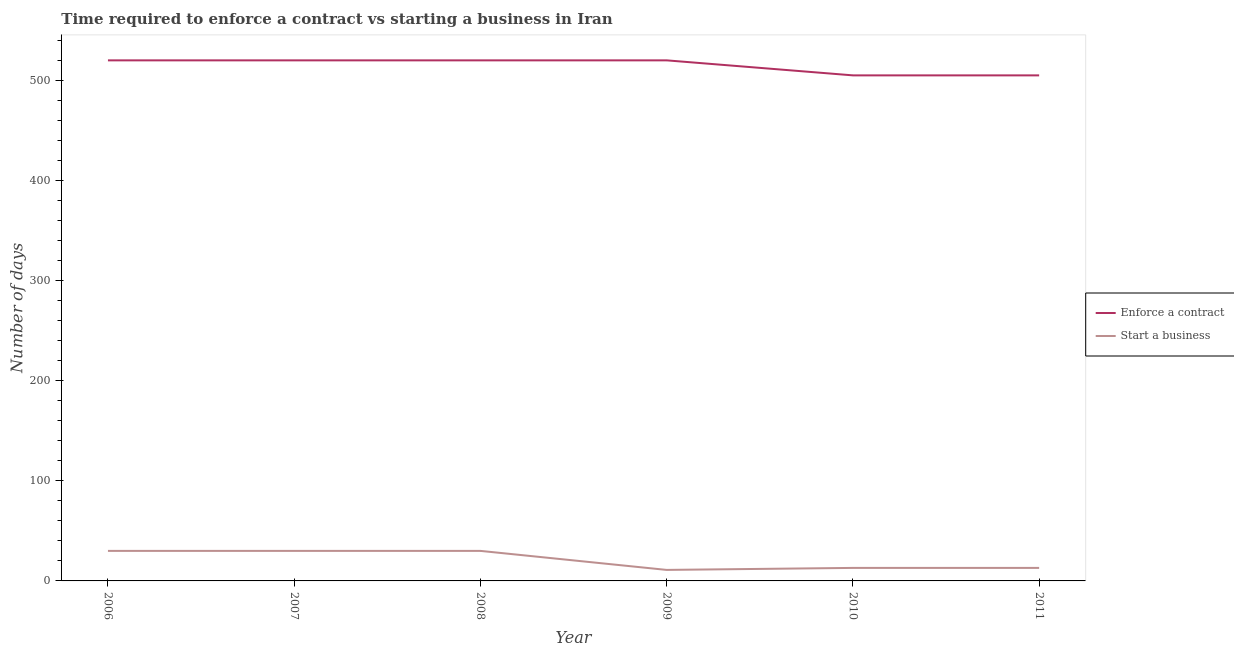How many different coloured lines are there?
Keep it short and to the point. 2. Does the line corresponding to number of days to enforece a contract intersect with the line corresponding to number of days to start a business?
Ensure brevity in your answer.  No. Is the number of lines equal to the number of legend labels?
Your response must be concise. Yes. What is the number of days to start a business in 2007?
Ensure brevity in your answer.  30. Across all years, what is the maximum number of days to start a business?
Provide a short and direct response. 30. Across all years, what is the minimum number of days to start a business?
Your answer should be very brief. 11. What is the total number of days to start a business in the graph?
Your answer should be very brief. 127. What is the difference between the number of days to enforece a contract in 2008 and the number of days to start a business in 2010?
Offer a terse response. 507. What is the average number of days to enforece a contract per year?
Offer a terse response. 515. In the year 2006, what is the difference between the number of days to start a business and number of days to enforece a contract?
Offer a very short reply. -490. In how many years, is the number of days to enforece a contract greater than 520 days?
Your answer should be compact. 0. What is the ratio of the number of days to start a business in 2007 to that in 2009?
Ensure brevity in your answer.  2.73. Is the difference between the number of days to start a business in 2009 and 2010 greater than the difference between the number of days to enforece a contract in 2009 and 2010?
Offer a terse response. No. What is the difference between the highest and the lowest number of days to enforece a contract?
Your answer should be compact. 15. In how many years, is the number of days to start a business greater than the average number of days to start a business taken over all years?
Offer a very short reply. 3. Does the number of days to start a business monotonically increase over the years?
Make the answer very short. No. Is the number of days to enforece a contract strictly less than the number of days to start a business over the years?
Ensure brevity in your answer.  No. How many years are there in the graph?
Provide a short and direct response. 6. What is the difference between two consecutive major ticks on the Y-axis?
Keep it short and to the point. 100. Does the graph contain grids?
Your answer should be very brief. No. Where does the legend appear in the graph?
Provide a succinct answer. Center right. How many legend labels are there?
Give a very brief answer. 2. What is the title of the graph?
Offer a terse response. Time required to enforce a contract vs starting a business in Iran. Does "Secondary education" appear as one of the legend labels in the graph?
Provide a succinct answer. No. What is the label or title of the Y-axis?
Your answer should be very brief. Number of days. What is the Number of days in Enforce a contract in 2006?
Offer a terse response. 520. What is the Number of days in Enforce a contract in 2007?
Your answer should be very brief. 520. What is the Number of days in Enforce a contract in 2008?
Provide a short and direct response. 520. What is the Number of days in Enforce a contract in 2009?
Give a very brief answer. 520. What is the Number of days of Start a business in 2009?
Provide a succinct answer. 11. What is the Number of days of Enforce a contract in 2010?
Your answer should be compact. 505. What is the Number of days in Start a business in 2010?
Keep it short and to the point. 13. What is the Number of days of Enforce a contract in 2011?
Make the answer very short. 505. What is the Number of days of Start a business in 2011?
Ensure brevity in your answer.  13. Across all years, what is the maximum Number of days of Enforce a contract?
Offer a terse response. 520. Across all years, what is the minimum Number of days of Enforce a contract?
Make the answer very short. 505. Across all years, what is the minimum Number of days of Start a business?
Your answer should be very brief. 11. What is the total Number of days of Enforce a contract in the graph?
Your response must be concise. 3090. What is the total Number of days of Start a business in the graph?
Make the answer very short. 127. What is the difference between the Number of days of Enforce a contract in 2006 and that in 2007?
Keep it short and to the point. 0. What is the difference between the Number of days of Start a business in 2006 and that in 2007?
Your response must be concise. 0. What is the difference between the Number of days of Start a business in 2006 and that in 2008?
Your answer should be compact. 0. What is the difference between the Number of days in Enforce a contract in 2006 and that in 2009?
Make the answer very short. 0. What is the difference between the Number of days in Enforce a contract in 2006 and that in 2010?
Provide a short and direct response. 15. What is the difference between the Number of days of Start a business in 2007 and that in 2008?
Make the answer very short. 0. What is the difference between the Number of days of Enforce a contract in 2007 and that in 2009?
Your answer should be very brief. 0. What is the difference between the Number of days of Enforce a contract in 2007 and that in 2010?
Your answer should be compact. 15. What is the difference between the Number of days in Start a business in 2007 and that in 2011?
Give a very brief answer. 17. What is the difference between the Number of days in Start a business in 2008 and that in 2009?
Offer a terse response. 19. What is the difference between the Number of days in Enforce a contract in 2008 and that in 2010?
Your response must be concise. 15. What is the difference between the Number of days of Start a business in 2008 and that in 2010?
Ensure brevity in your answer.  17. What is the difference between the Number of days of Enforce a contract in 2008 and that in 2011?
Offer a terse response. 15. What is the difference between the Number of days in Enforce a contract in 2010 and that in 2011?
Your answer should be compact. 0. What is the difference between the Number of days in Start a business in 2010 and that in 2011?
Your response must be concise. 0. What is the difference between the Number of days in Enforce a contract in 2006 and the Number of days in Start a business in 2007?
Provide a succinct answer. 490. What is the difference between the Number of days in Enforce a contract in 2006 and the Number of days in Start a business in 2008?
Your answer should be very brief. 490. What is the difference between the Number of days of Enforce a contract in 2006 and the Number of days of Start a business in 2009?
Provide a succinct answer. 509. What is the difference between the Number of days in Enforce a contract in 2006 and the Number of days in Start a business in 2010?
Ensure brevity in your answer.  507. What is the difference between the Number of days in Enforce a contract in 2006 and the Number of days in Start a business in 2011?
Offer a very short reply. 507. What is the difference between the Number of days in Enforce a contract in 2007 and the Number of days in Start a business in 2008?
Provide a succinct answer. 490. What is the difference between the Number of days of Enforce a contract in 2007 and the Number of days of Start a business in 2009?
Offer a very short reply. 509. What is the difference between the Number of days of Enforce a contract in 2007 and the Number of days of Start a business in 2010?
Provide a succinct answer. 507. What is the difference between the Number of days in Enforce a contract in 2007 and the Number of days in Start a business in 2011?
Provide a succinct answer. 507. What is the difference between the Number of days in Enforce a contract in 2008 and the Number of days in Start a business in 2009?
Give a very brief answer. 509. What is the difference between the Number of days in Enforce a contract in 2008 and the Number of days in Start a business in 2010?
Keep it short and to the point. 507. What is the difference between the Number of days in Enforce a contract in 2008 and the Number of days in Start a business in 2011?
Offer a terse response. 507. What is the difference between the Number of days in Enforce a contract in 2009 and the Number of days in Start a business in 2010?
Make the answer very short. 507. What is the difference between the Number of days of Enforce a contract in 2009 and the Number of days of Start a business in 2011?
Make the answer very short. 507. What is the difference between the Number of days of Enforce a contract in 2010 and the Number of days of Start a business in 2011?
Give a very brief answer. 492. What is the average Number of days of Enforce a contract per year?
Your answer should be very brief. 515. What is the average Number of days in Start a business per year?
Ensure brevity in your answer.  21.17. In the year 2006, what is the difference between the Number of days of Enforce a contract and Number of days of Start a business?
Keep it short and to the point. 490. In the year 2007, what is the difference between the Number of days in Enforce a contract and Number of days in Start a business?
Provide a succinct answer. 490. In the year 2008, what is the difference between the Number of days in Enforce a contract and Number of days in Start a business?
Provide a short and direct response. 490. In the year 2009, what is the difference between the Number of days in Enforce a contract and Number of days in Start a business?
Give a very brief answer. 509. In the year 2010, what is the difference between the Number of days in Enforce a contract and Number of days in Start a business?
Your answer should be compact. 492. In the year 2011, what is the difference between the Number of days of Enforce a contract and Number of days of Start a business?
Make the answer very short. 492. What is the ratio of the Number of days of Enforce a contract in 2006 to that in 2008?
Your answer should be compact. 1. What is the ratio of the Number of days in Start a business in 2006 to that in 2009?
Provide a short and direct response. 2.73. What is the ratio of the Number of days in Enforce a contract in 2006 to that in 2010?
Make the answer very short. 1.03. What is the ratio of the Number of days of Start a business in 2006 to that in 2010?
Make the answer very short. 2.31. What is the ratio of the Number of days in Enforce a contract in 2006 to that in 2011?
Offer a terse response. 1.03. What is the ratio of the Number of days in Start a business in 2006 to that in 2011?
Give a very brief answer. 2.31. What is the ratio of the Number of days of Enforce a contract in 2007 to that in 2009?
Offer a very short reply. 1. What is the ratio of the Number of days of Start a business in 2007 to that in 2009?
Provide a succinct answer. 2.73. What is the ratio of the Number of days of Enforce a contract in 2007 to that in 2010?
Provide a succinct answer. 1.03. What is the ratio of the Number of days of Start a business in 2007 to that in 2010?
Your response must be concise. 2.31. What is the ratio of the Number of days of Enforce a contract in 2007 to that in 2011?
Make the answer very short. 1.03. What is the ratio of the Number of days of Start a business in 2007 to that in 2011?
Offer a very short reply. 2.31. What is the ratio of the Number of days of Enforce a contract in 2008 to that in 2009?
Your answer should be very brief. 1. What is the ratio of the Number of days in Start a business in 2008 to that in 2009?
Keep it short and to the point. 2.73. What is the ratio of the Number of days in Enforce a contract in 2008 to that in 2010?
Your answer should be very brief. 1.03. What is the ratio of the Number of days of Start a business in 2008 to that in 2010?
Provide a succinct answer. 2.31. What is the ratio of the Number of days in Enforce a contract in 2008 to that in 2011?
Make the answer very short. 1.03. What is the ratio of the Number of days of Start a business in 2008 to that in 2011?
Offer a very short reply. 2.31. What is the ratio of the Number of days in Enforce a contract in 2009 to that in 2010?
Provide a short and direct response. 1.03. What is the ratio of the Number of days in Start a business in 2009 to that in 2010?
Offer a very short reply. 0.85. What is the ratio of the Number of days in Enforce a contract in 2009 to that in 2011?
Your answer should be very brief. 1.03. What is the ratio of the Number of days in Start a business in 2009 to that in 2011?
Offer a very short reply. 0.85. What is the difference between the highest and the second highest Number of days in Start a business?
Give a very brief answer. 0. What is the difference between the highest and the lowest Number of days in Enforce a contract?
Provide a short and direct response. 15. 